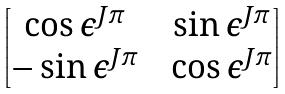Convert formula to latex. <formula><loc_0><loc_0><loc_500><loc_500>\begin{bmatrix} \cos \epsilon ^ { J \pi } & & \sin \epsilon ^ { J \pi } \\ - \sin \epsilon ^ { J \pi } & & \cos \epsilon ^ { J \pi } \end{bmatrix}</formula> 